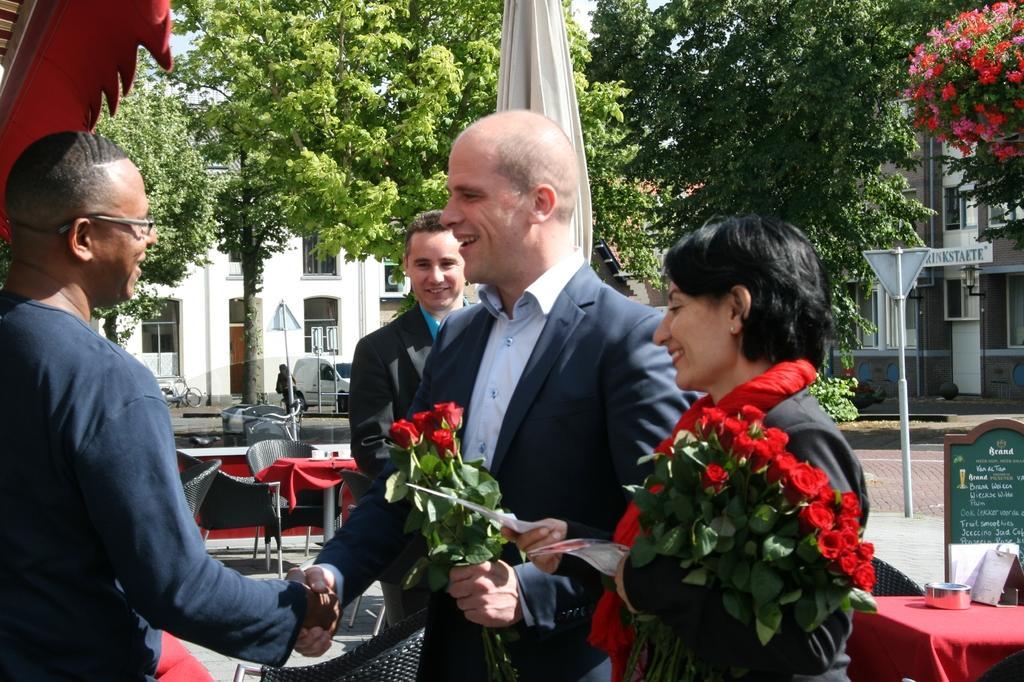Could you give a brief overview of what you see in this image? A man is shaking hand with other one beside she is a woman behind them there are trees buildings. 